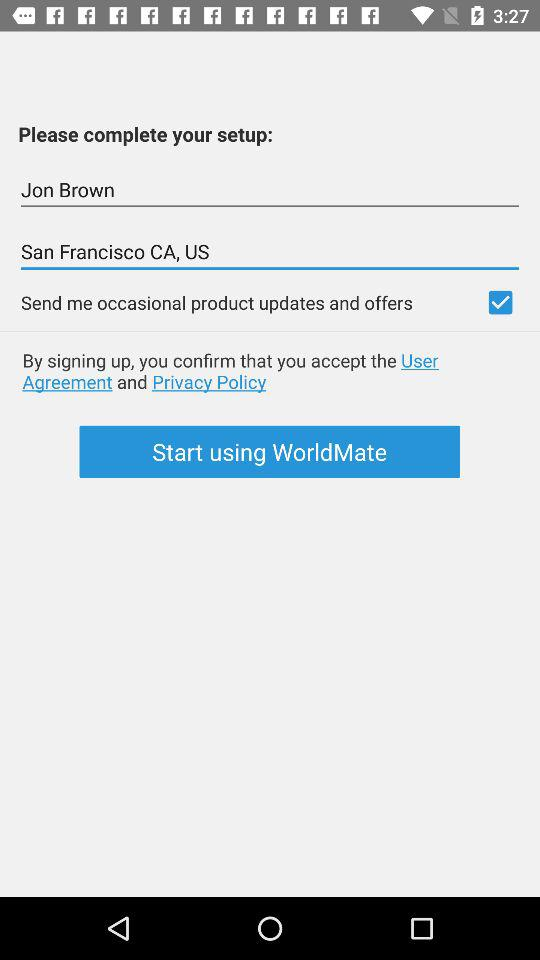What is the name? The name is Jon Brown. 